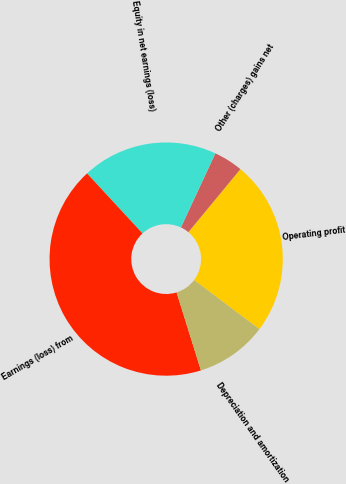Convert chart. <chart><loc_0><loc_0><loc_500><loc_500><pie_chart><fcel>Operating profit<fcel>Other (charges) gains net<fcel>Equity in net earnings (loss)<fcel>Earnings (loss) from<fcel>Depreciation and amortization<nl><fcel>24.28%<fcel>4.05%<fcel>18.8%<fcel>42.95%<fcel>9.92%<nl></chart> 